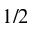<formula> <loc_0><loc_0><loc_500><loc_500>1 / 2</formula> 